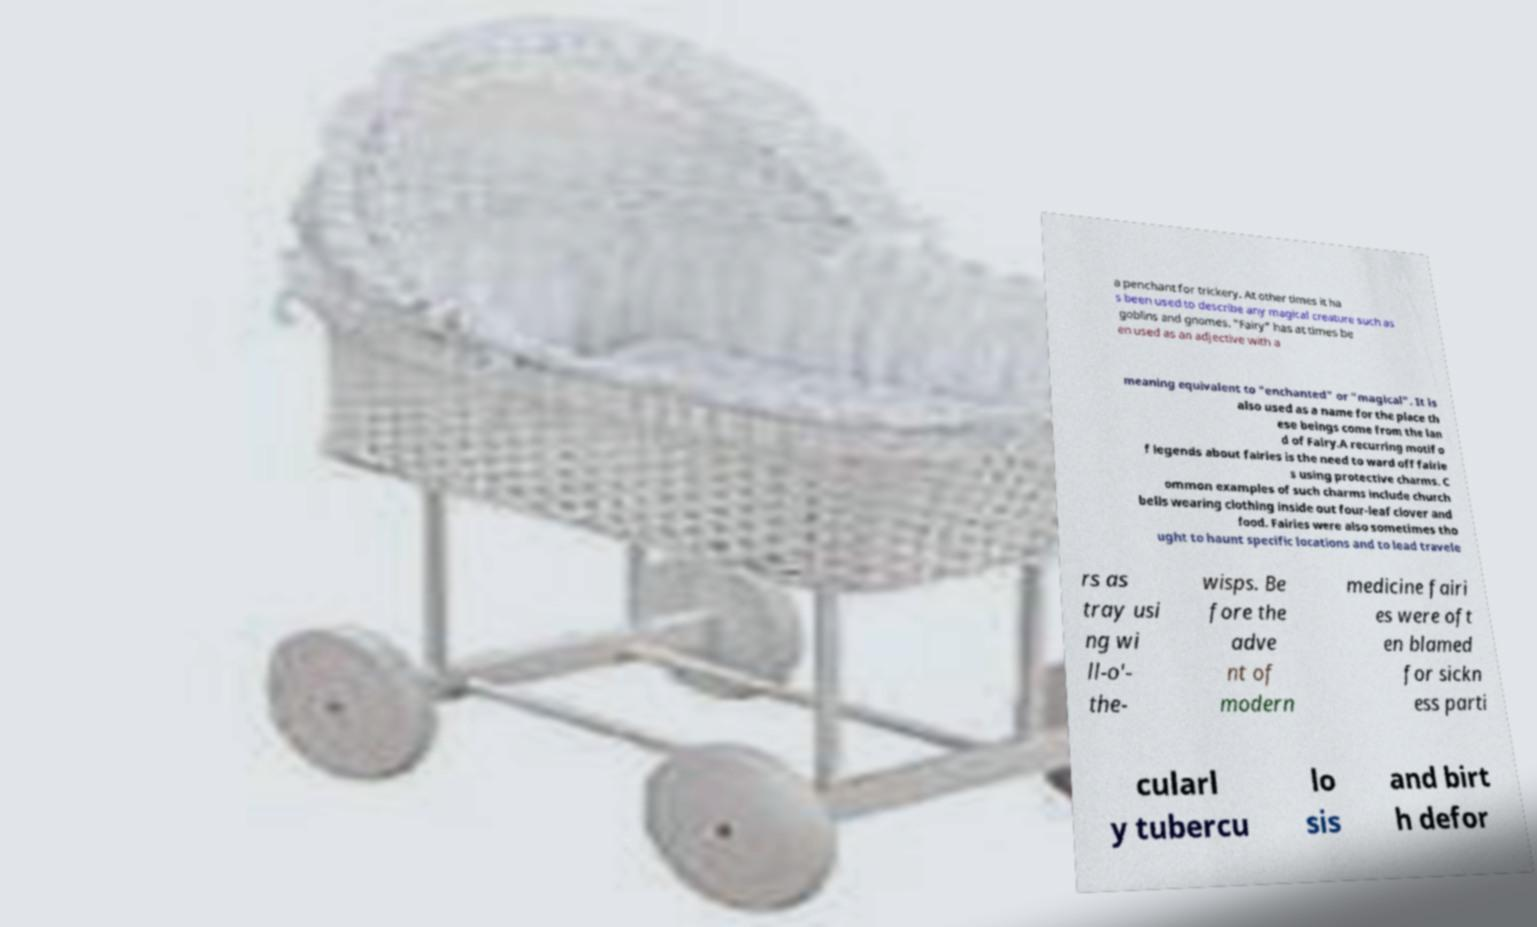I need the written content from this picture converted into text. Can you do that? a penchant for trickery. At other times it ha s been used to describe any magical creature such as goblins and gnomes. "Fairy" has at times be en used as an adjective with a meaning equivalent to "enchanted" or "magical". It is also used as a name for the place th ese beings come from the lan d of Fairy.A recurring motif o f legends about fairies is the need to ward off fairie s using protective charms. C ommon examples of such charms include church bells wearing clothing inside out four-leaf clover and food. Fairies were also sometimes tho ught to haunt specific locations and to lead travele rs as tray usi ng wi ll-o'- the- wisps. Be fore the adve nt of modern medicine fairi es were oft en blamed for sickn ess parti cularl y tubercu lo sis and birt h defor 